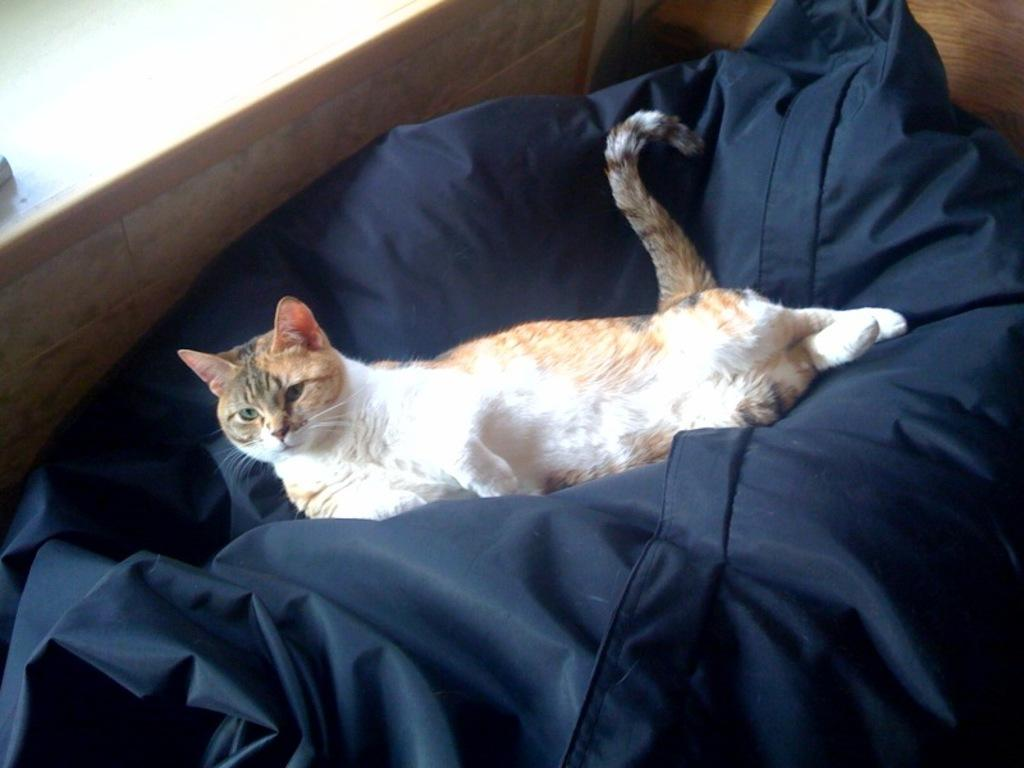What type of animal can be seen in the image? There is a cat in the image. Where is the cat located? The cat is lying on a bed. What is visible beside the bed in the image? There is a wall beside the bed in the image. What type of bread can be seen in the image? There is no bread present in the image; it features a cat lying on a bed. Can you describe the trail left by the cat in the image? There is no trail left by the cat in the image; the cat is simply lying on the bed. 